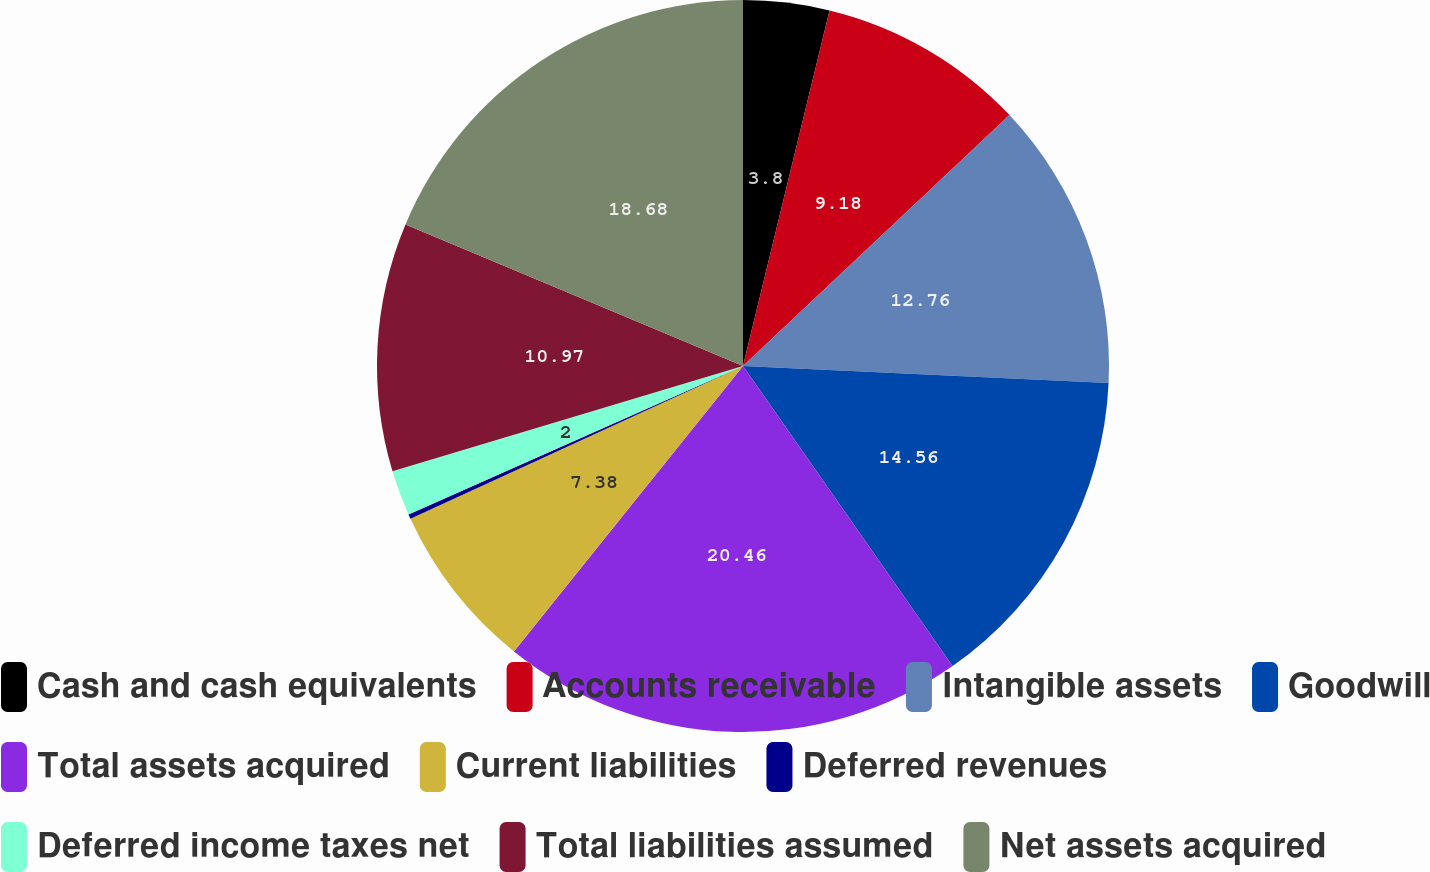Convert chart. <chart><loc_0><loc_0><loc_500><loc_500><pie_chart><fcel>Cash and cash equivalents<fcel>Accounts receivable<fcel>Intangible assets<fcel>Goodwill<fcel>Total assets acquired<fcel>Current liabilities<fcel>Deferred revenues<fcel>Deferred income taxes net<fcel>Total liabilities assumed<fcel>Net assets acquired<nl><fcel>3.8%<fcel>9.18%<fcel>12.76%<fcel>14.56%<fcel>20.47%<fcel>7.38%<fcel>0.21%<fcel>2.0%<fcel>10.97%<fcel>18.68%<nl></chart> 